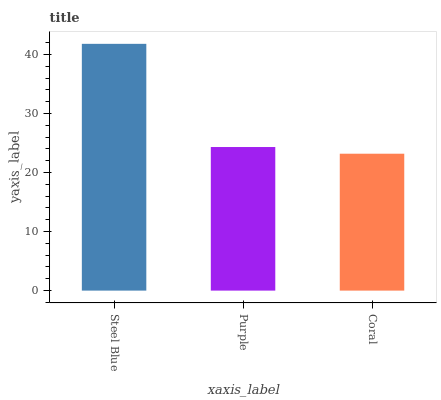Is Coral the minimum?
Answer yes or no. Yes. Is Steel Blue the maximum?
Answer yes or no. Yes. Is Purple the minimum?
Answer yes or no. No. Is Purple the maximum?
Answer yes or no. No. Is Steel Blue greater than Purple?
Answer yes or no. Yes. Is Purple less than Steel Blue?
Answer yes or no. Yes. Is Purple greater than Steel Blue?
Answer yes or no. No. Is Steel Blue less than Purple?
Answer yes or no. No. Is Purple the high median?
Answer yes or no. Yes. Is Purple the low median?
Answer yes or no. Yes. Is Steel Blue the high median?
Answer yes or no. No. Is Steel Blue the low median?
Answer yes or no. No. 